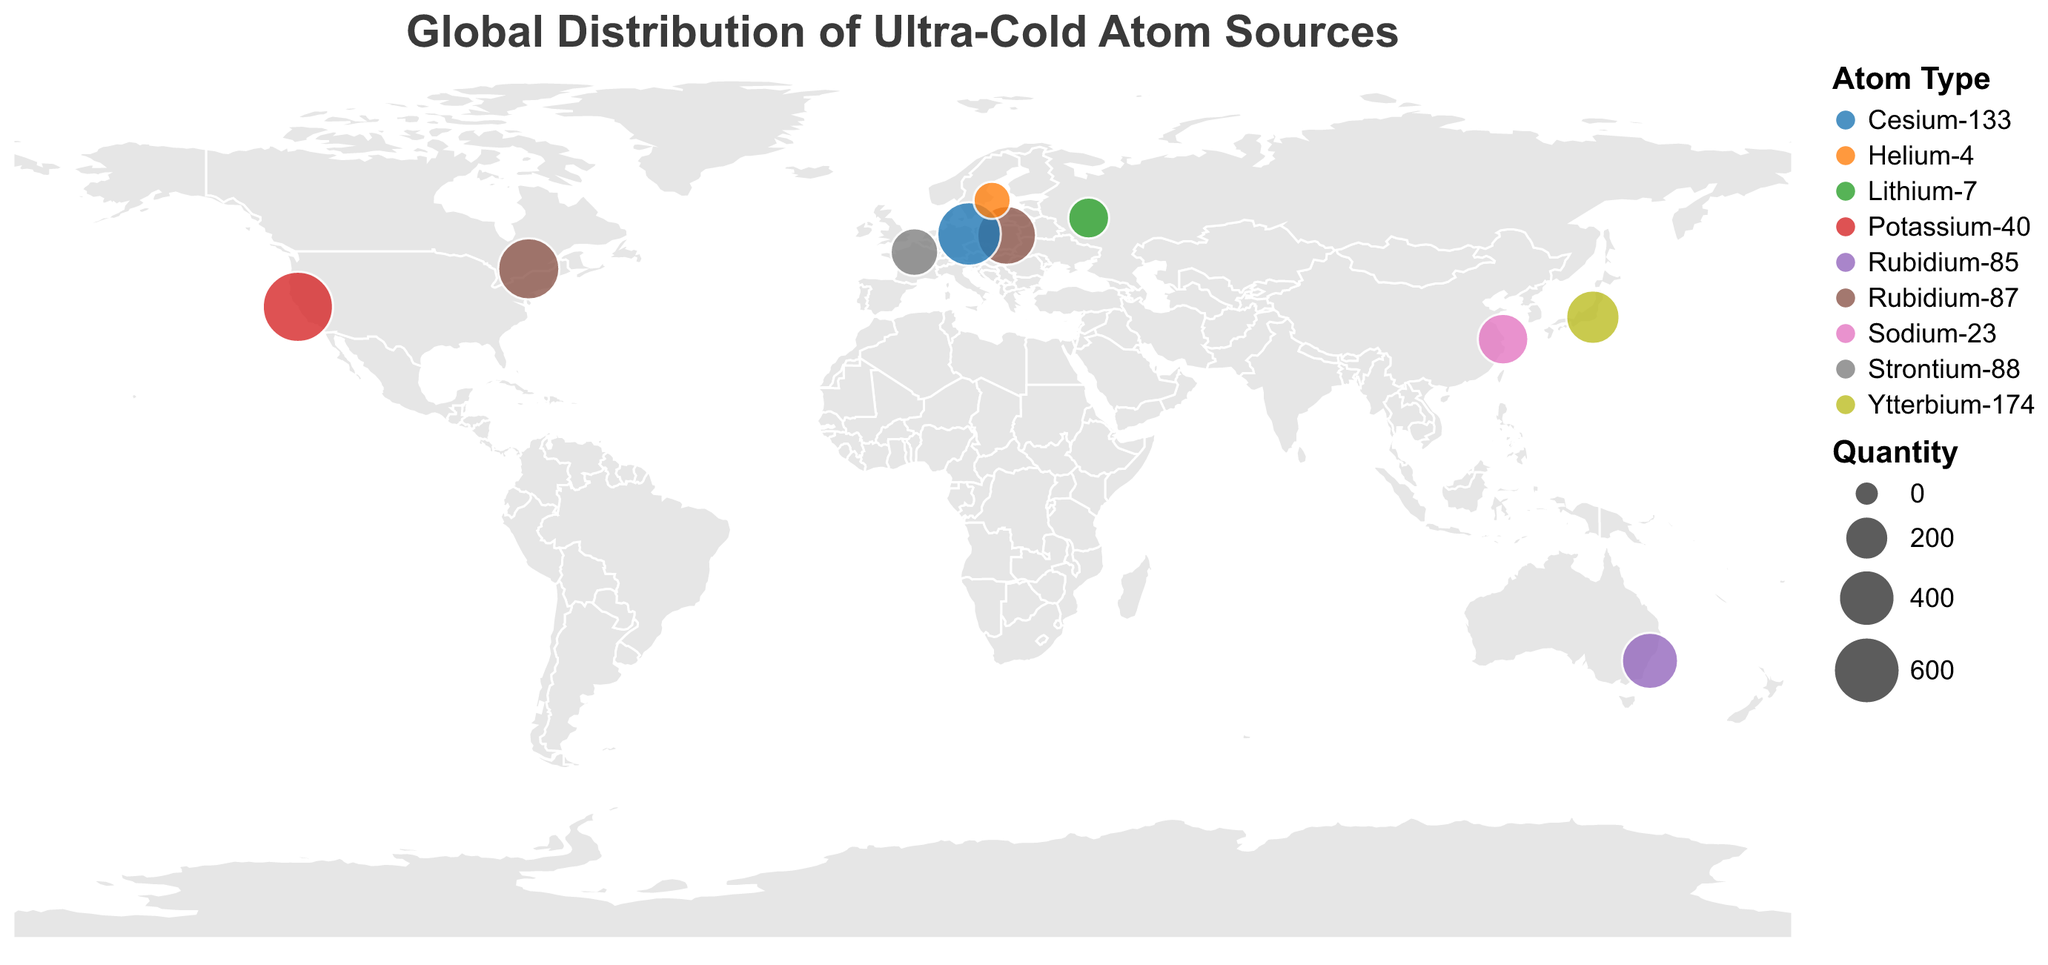What is the title of the figure? The title text is displayed at the top of the chart.
Answer: Global Distribution of Ultra-Cold Atom Sources Which company supplies the highest quantity of ultra-cold atom sources? Refer to the size of the circles representing each company; the largest indicates the highest quantity. ColdQuanta has the largest circle.
Answer: ColdQuanta How many types of ultra-cold atoms are displayed in the figure? Different colors represent different types of atoms. Count the unique colors in the legend.
Answer: 9 Which country has the most suppliers listed on the map? Count the circles in each country to determine the most frequent. The USA has more than one supplier.
Answer: USA What is the total quantity of ultra-cold atom sources supplied by European companies? Sum the quantities of ultra-cold atom sources from European-based companies: Poland (500) + France (300) + Germany (600) + Sweden (150).
Answer: 1550 Which type of ultra-cold atom is supplied by the company in Sweden? Identify the color of the circle located in Sweden and refer to the legend for the corresponding atom type.
Answer: Helium-4 Compare the quantities of Rubidium-87 supplied by TopticaPL and D-Wave Systems. Which one supplies more? Compare the circle sizes for TopticaPL (500) and D-Wave Systems (550).
Answer: D-Wave Systems Which company from an Asian country supplies the largest quantity of ultra-cold atom sources? Look for the Asian countries and compare the circle sizes of corresponding companies. In China, Japan, and Russia, the largest quantity is by Shanghai Institute of Optics and Fine Mechanics (350) from China.
Answer: Shanghai Institute of Optics and Fine Mechanics How many companies supply Rubidium isotopes, and what are the total quantities for each? Search for Rubidium isotopes in the legend and count corresponding companies. Sum the quantities for each isotope: TopticaPL (500) + D-Wave Systems (550) + MOGLabs (450).
Answer: 3 companies, Rubidium-87: 1050, Rubidium-85: 450 What is the average quantity of ultra-cold atom sources supplied by companies from North America? Calculate the average using data from the USA (750 from ColdQuanta) and Canada (550 from D-Wave Systems): (750 + 550) / 2.
Answer: 650 